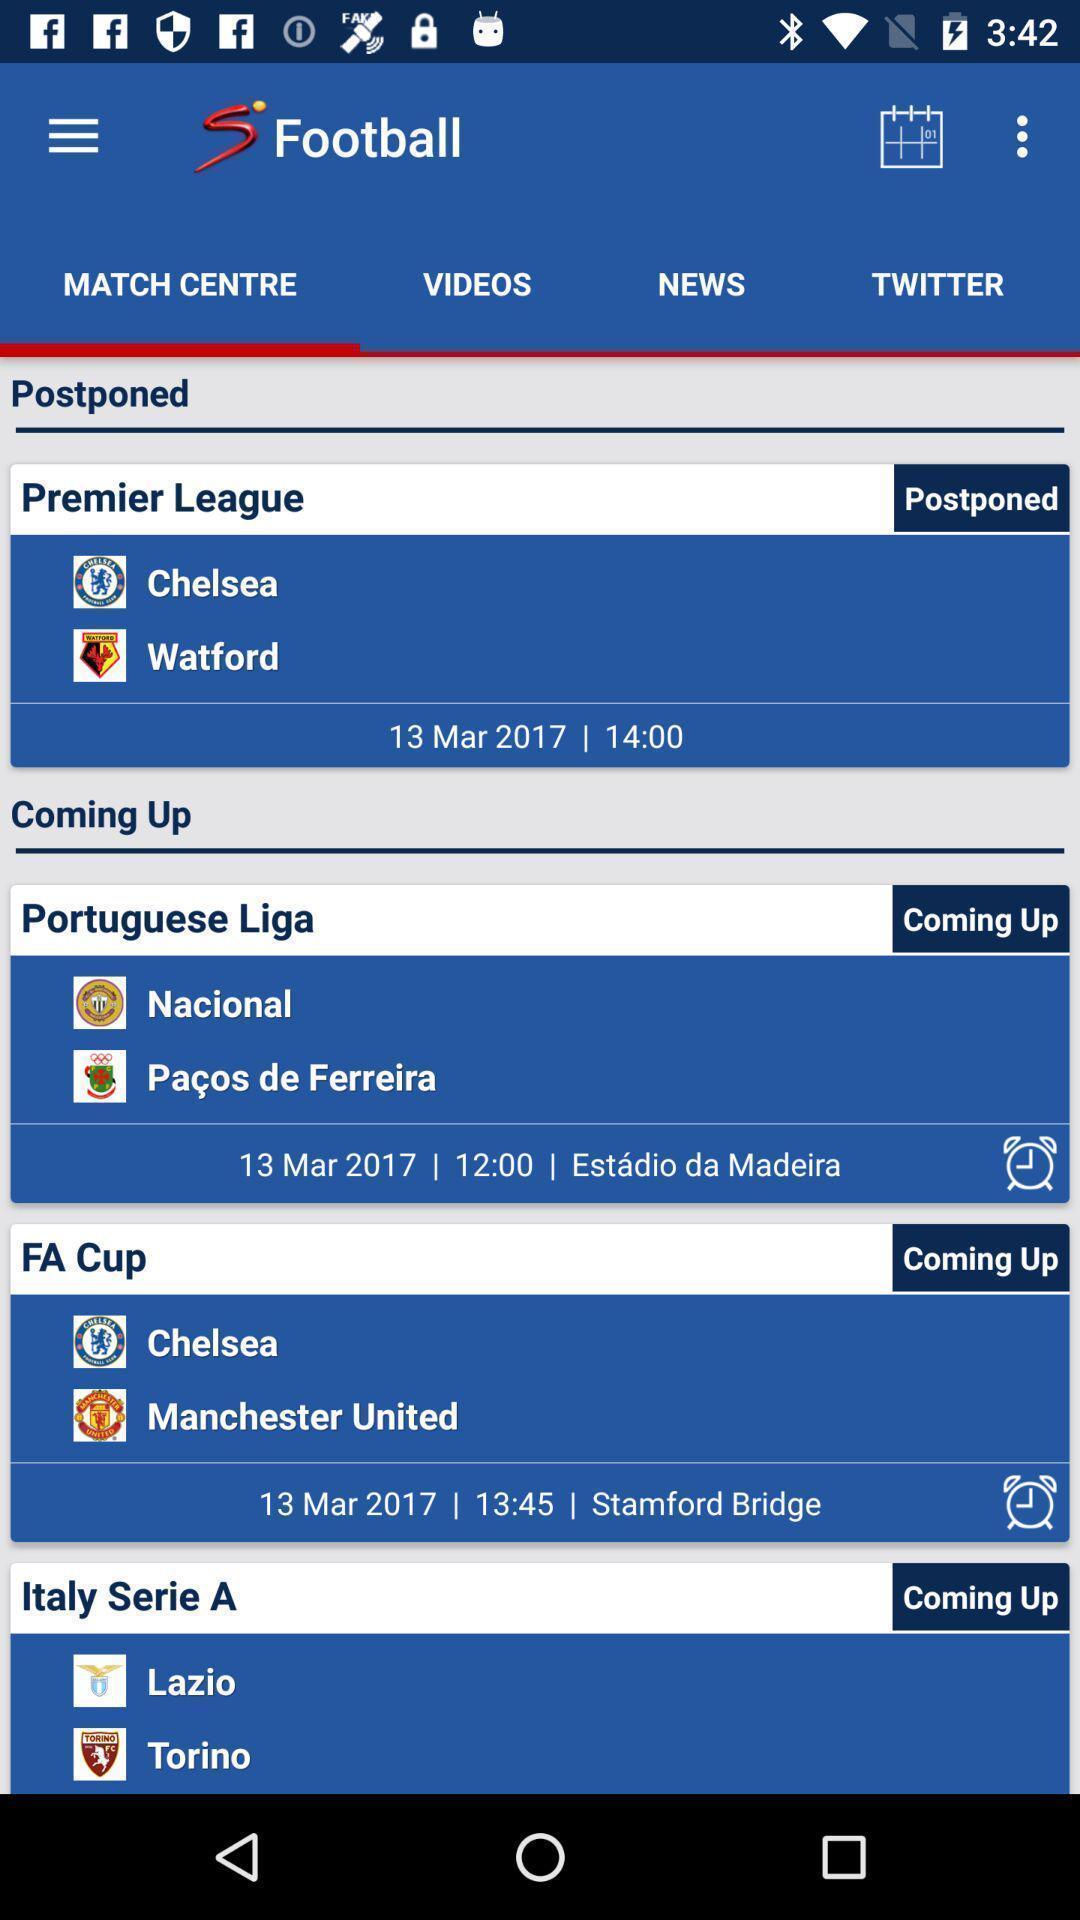What is the overall content of this screenshot? Page shows details. 